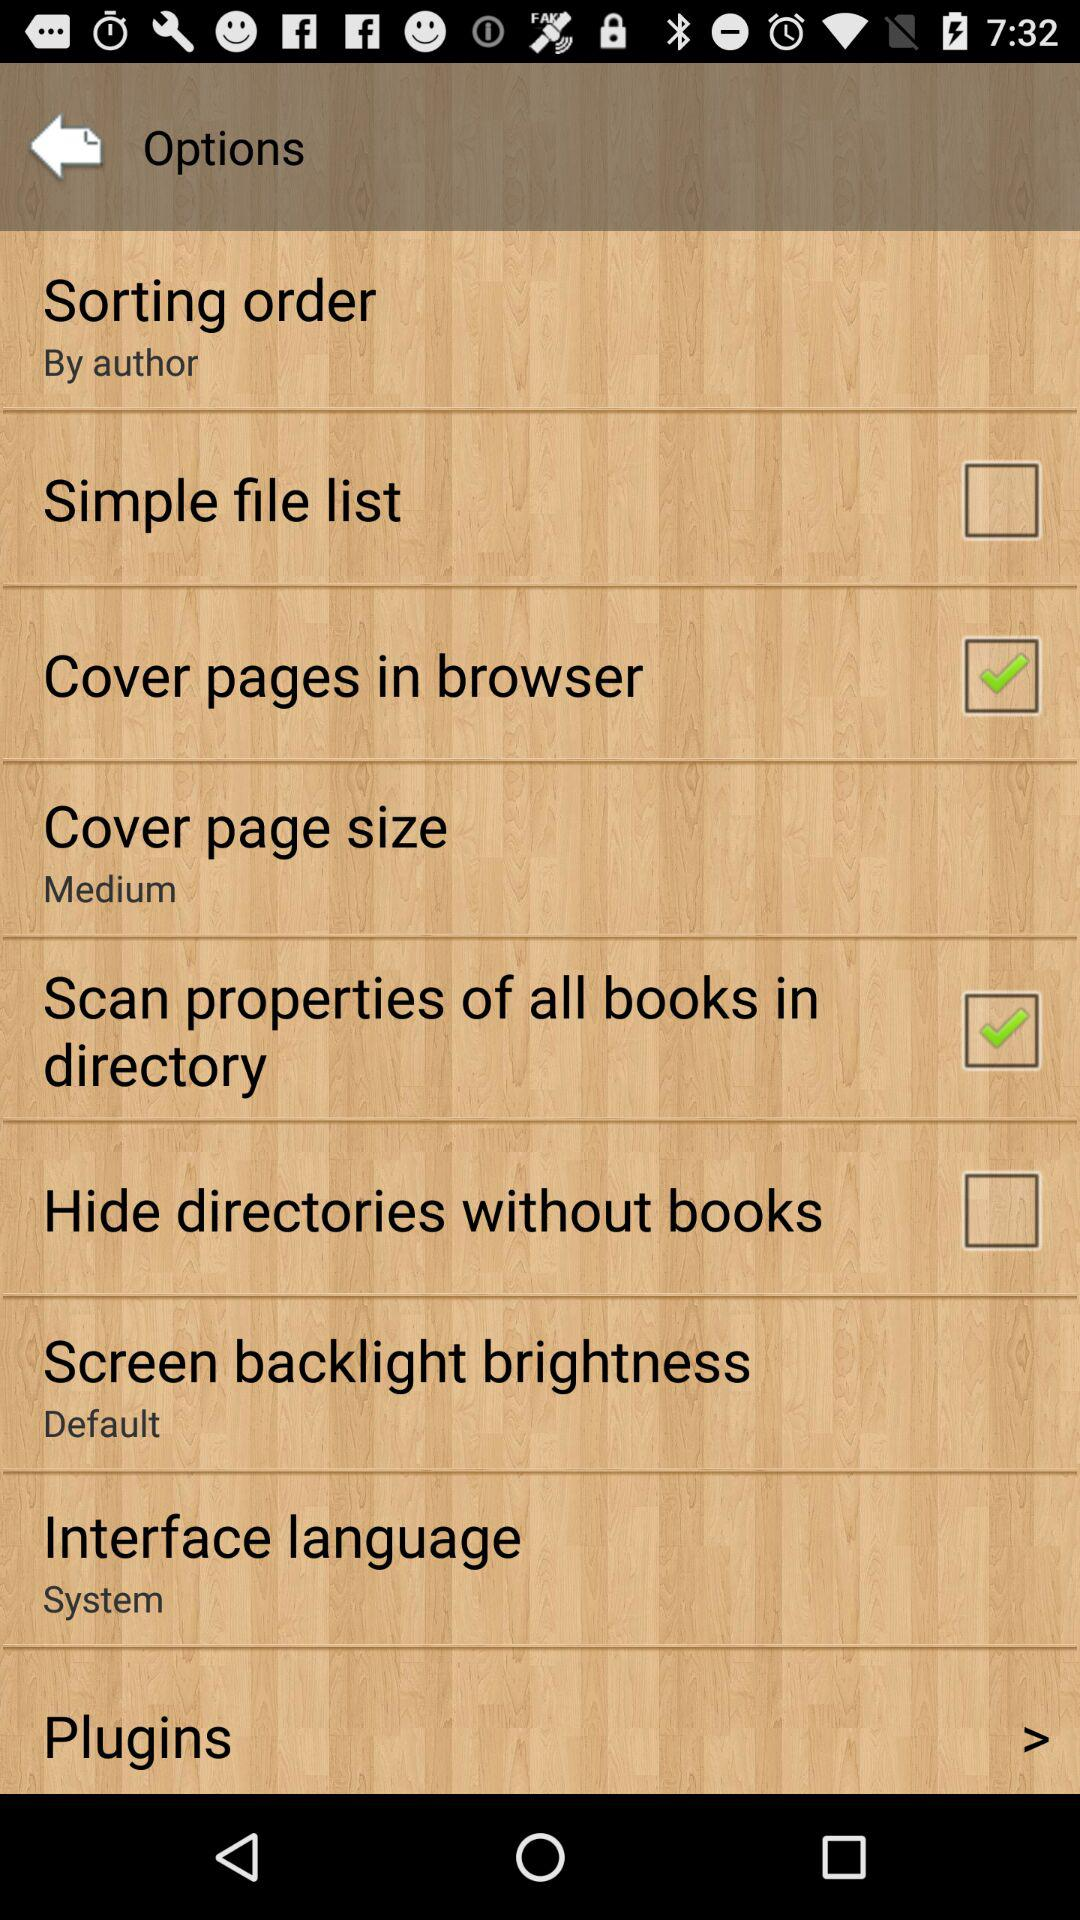What is the selected "Interface language"? The selected "Interface language" is "System". 